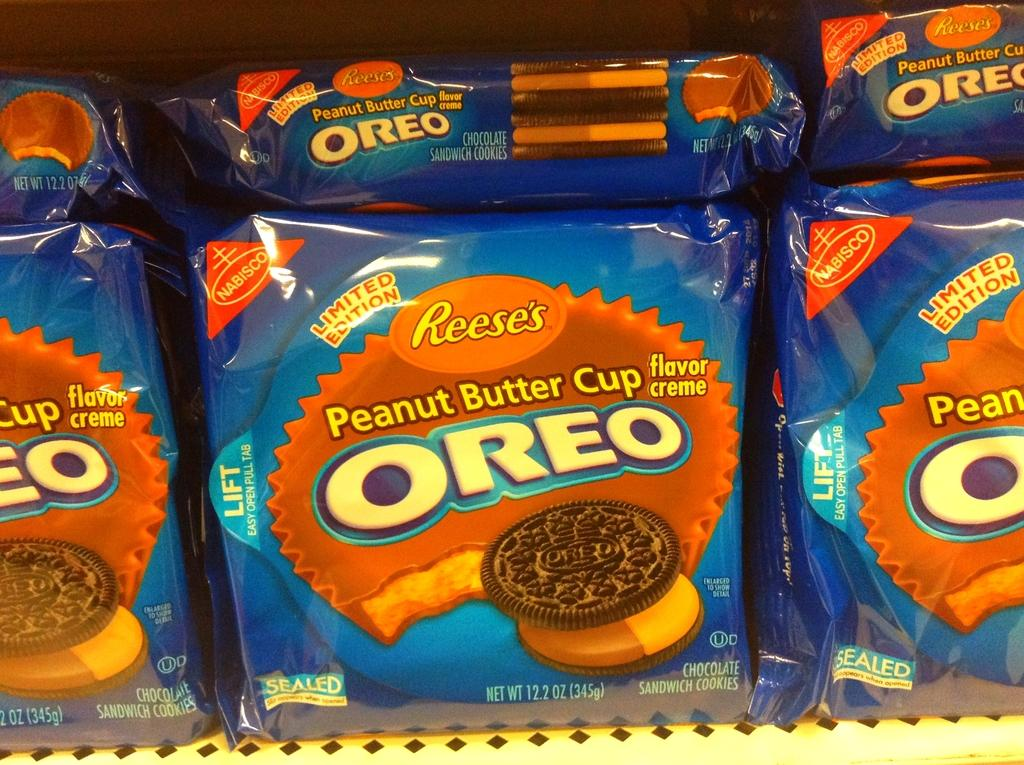What type of product is visible in the image? There are biscuit packets in the image. What color are the biscuit packets? The biscuit packets are blue in color. How are the biscuit packets arranged in the image? The biscuit packets are kept in a rack. How many beds are visible in the image? There are no beds present in the image; it features biscuit packets in a rack. What type of pot is used for cooking in the image? There is no pot present in the image; it only shows biscuit packets in a rack. 